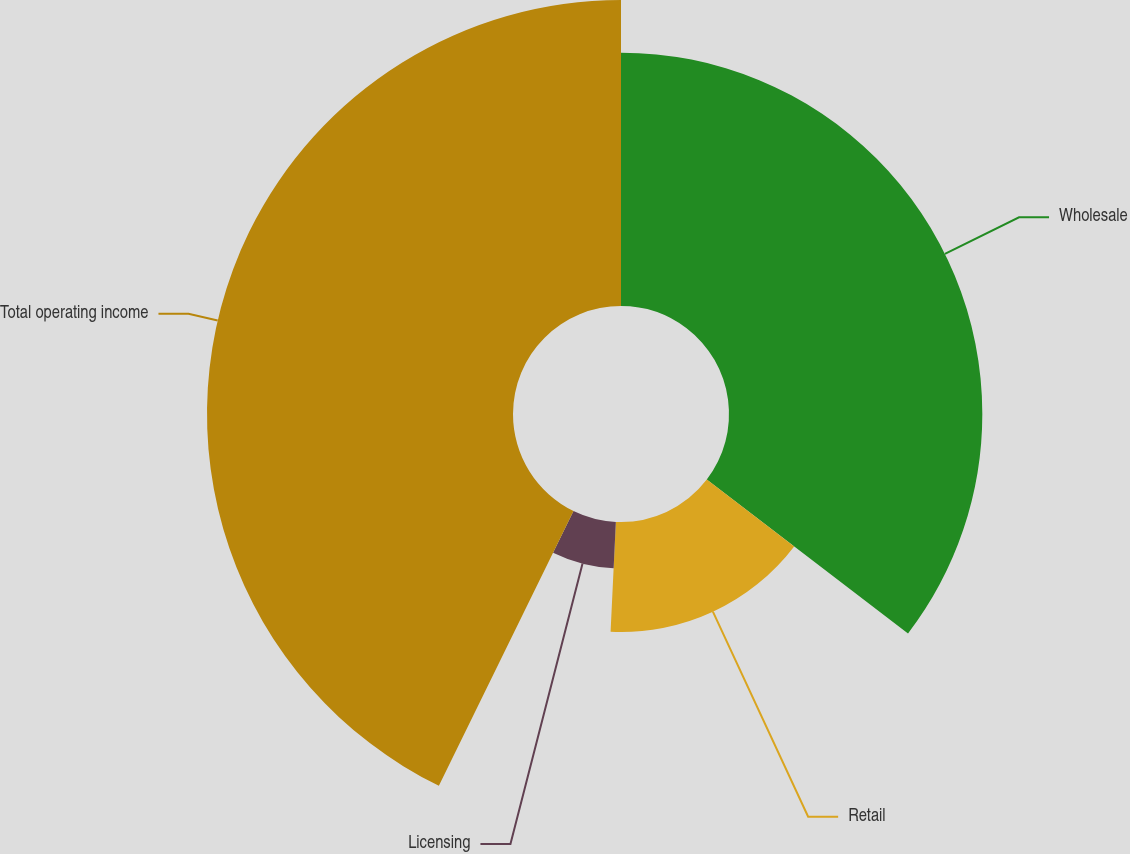Convert chart. <chart><loc_0><loc_0><loc_500><loc_500><pie_chart><fcel>Wholesale<fcel>Retail<fcel>Licensing<fcel>Total operating income<nl><fcel>35.39%<fcel>15.37%<fcel>6.49%<fcel>42.75%<nl></chart> 